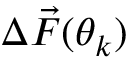<formula> <loc_0><loc_0><loc_500><loc_500>\Delta \vec { F } ( \theta _ { k } )</formula> 